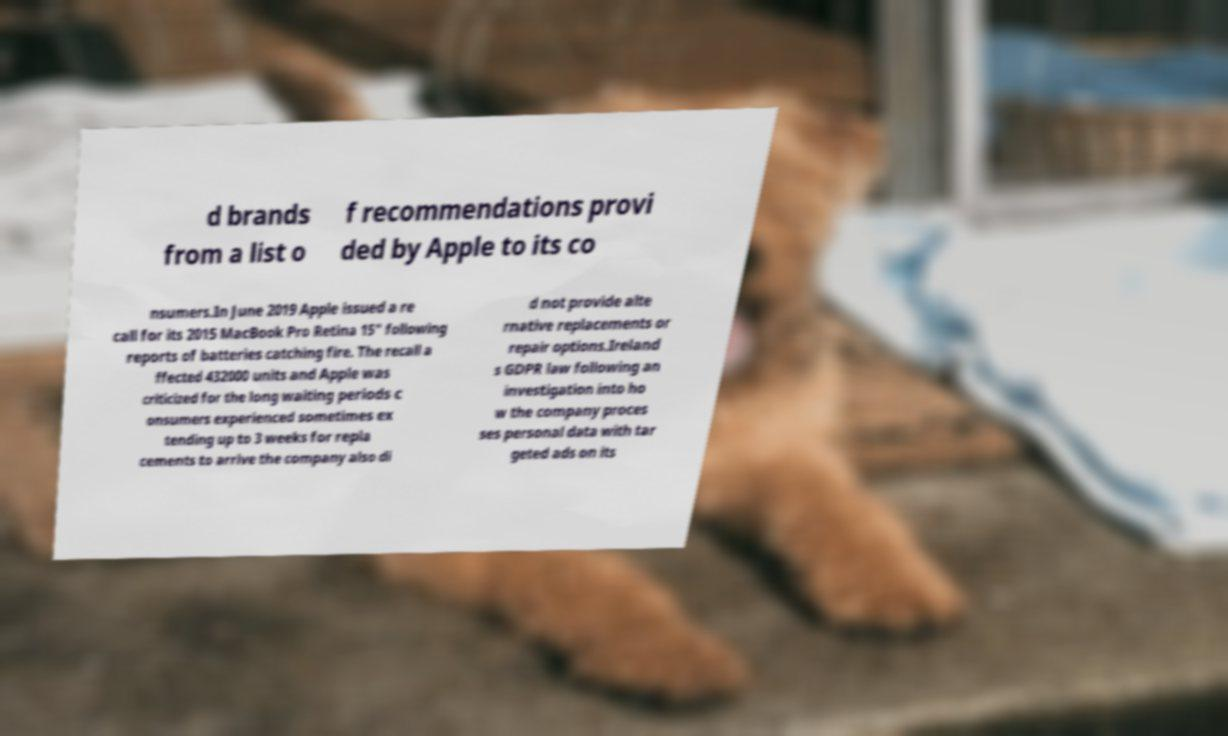What messages or text are displayed in this image? I need them in a readable, typed format. d brands from a list o f recommendations provi ded by Apple to its co nsumers.In June 2019 Apple issued a re call for its 2015 MacBook Pro Retina 15" following reports of batteries catching fire. The recall a ffected 432000 units and Apple was criticized for the long waiting periods c onsumers experienced sometimes ex tending up to 3 weeks for repla cements to arrive the company also di d not provide alte rnative replacements or repair options.Ireland s GDPR law following an investigation into ho w the company proces ses personal data with tar geted ads on its 